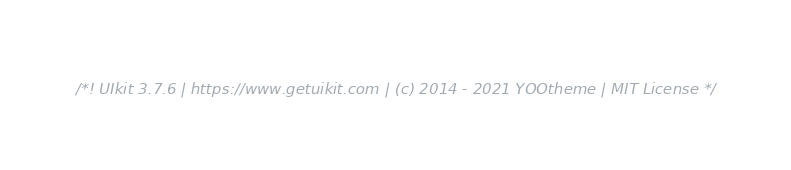<code> <loc_0><loc_0><loc_500><loc_500><_JavaScript_>/*! UIkit 3.7.6 | https://www.getuikit.com | (c) 2014 - 2021 YOOtheme | MIT License */</code> 